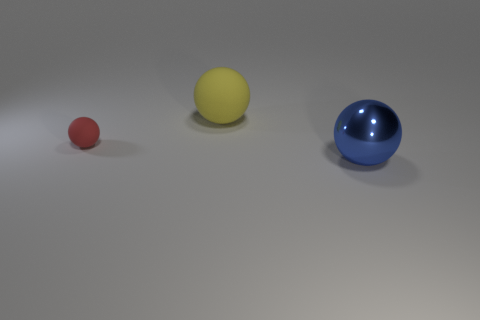What is the size of the red ball? The red ball is the smallest among the three balls in the image, with a size that appears to be less than half the diameter of the largest ball. 